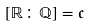<formula> <loc_0><loc_0><loc_500><loc_500>[ \mathbb { R } \colon \mathbb { Q } ] = { \mathfrak { c } }</formula> 